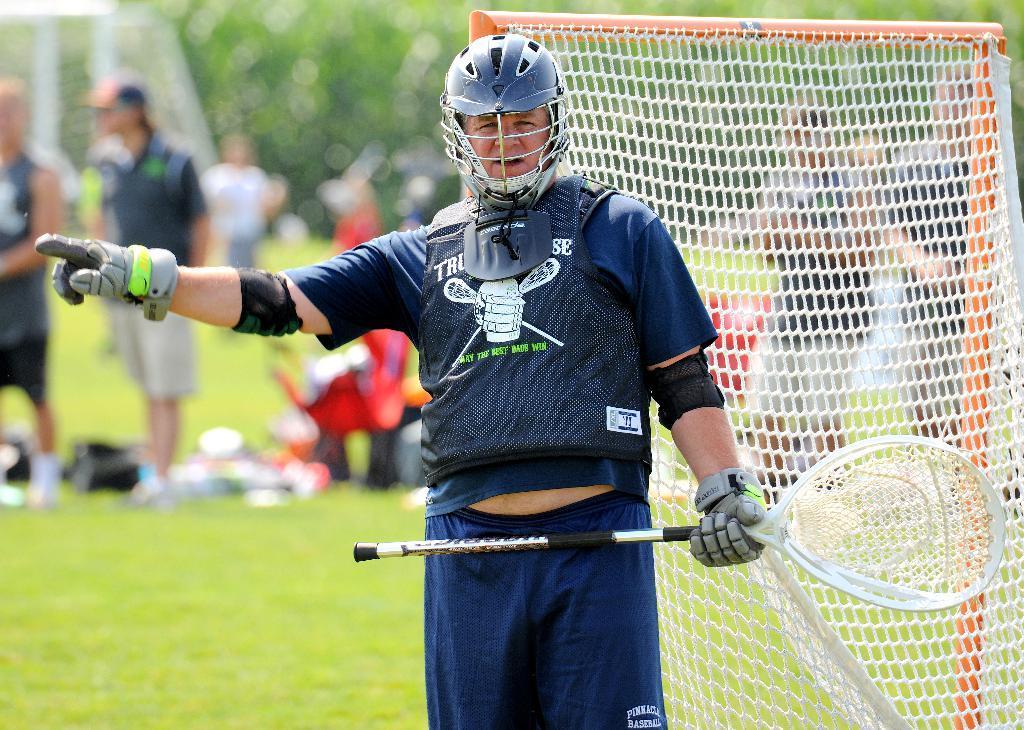In one or two sentences, can you explain what this image depicts? In the image there is a person in navy blue jersey,helmet and holding net standing in front of goal post on the grassland and in the back there are many people standing on the land followed by trees in the background. 